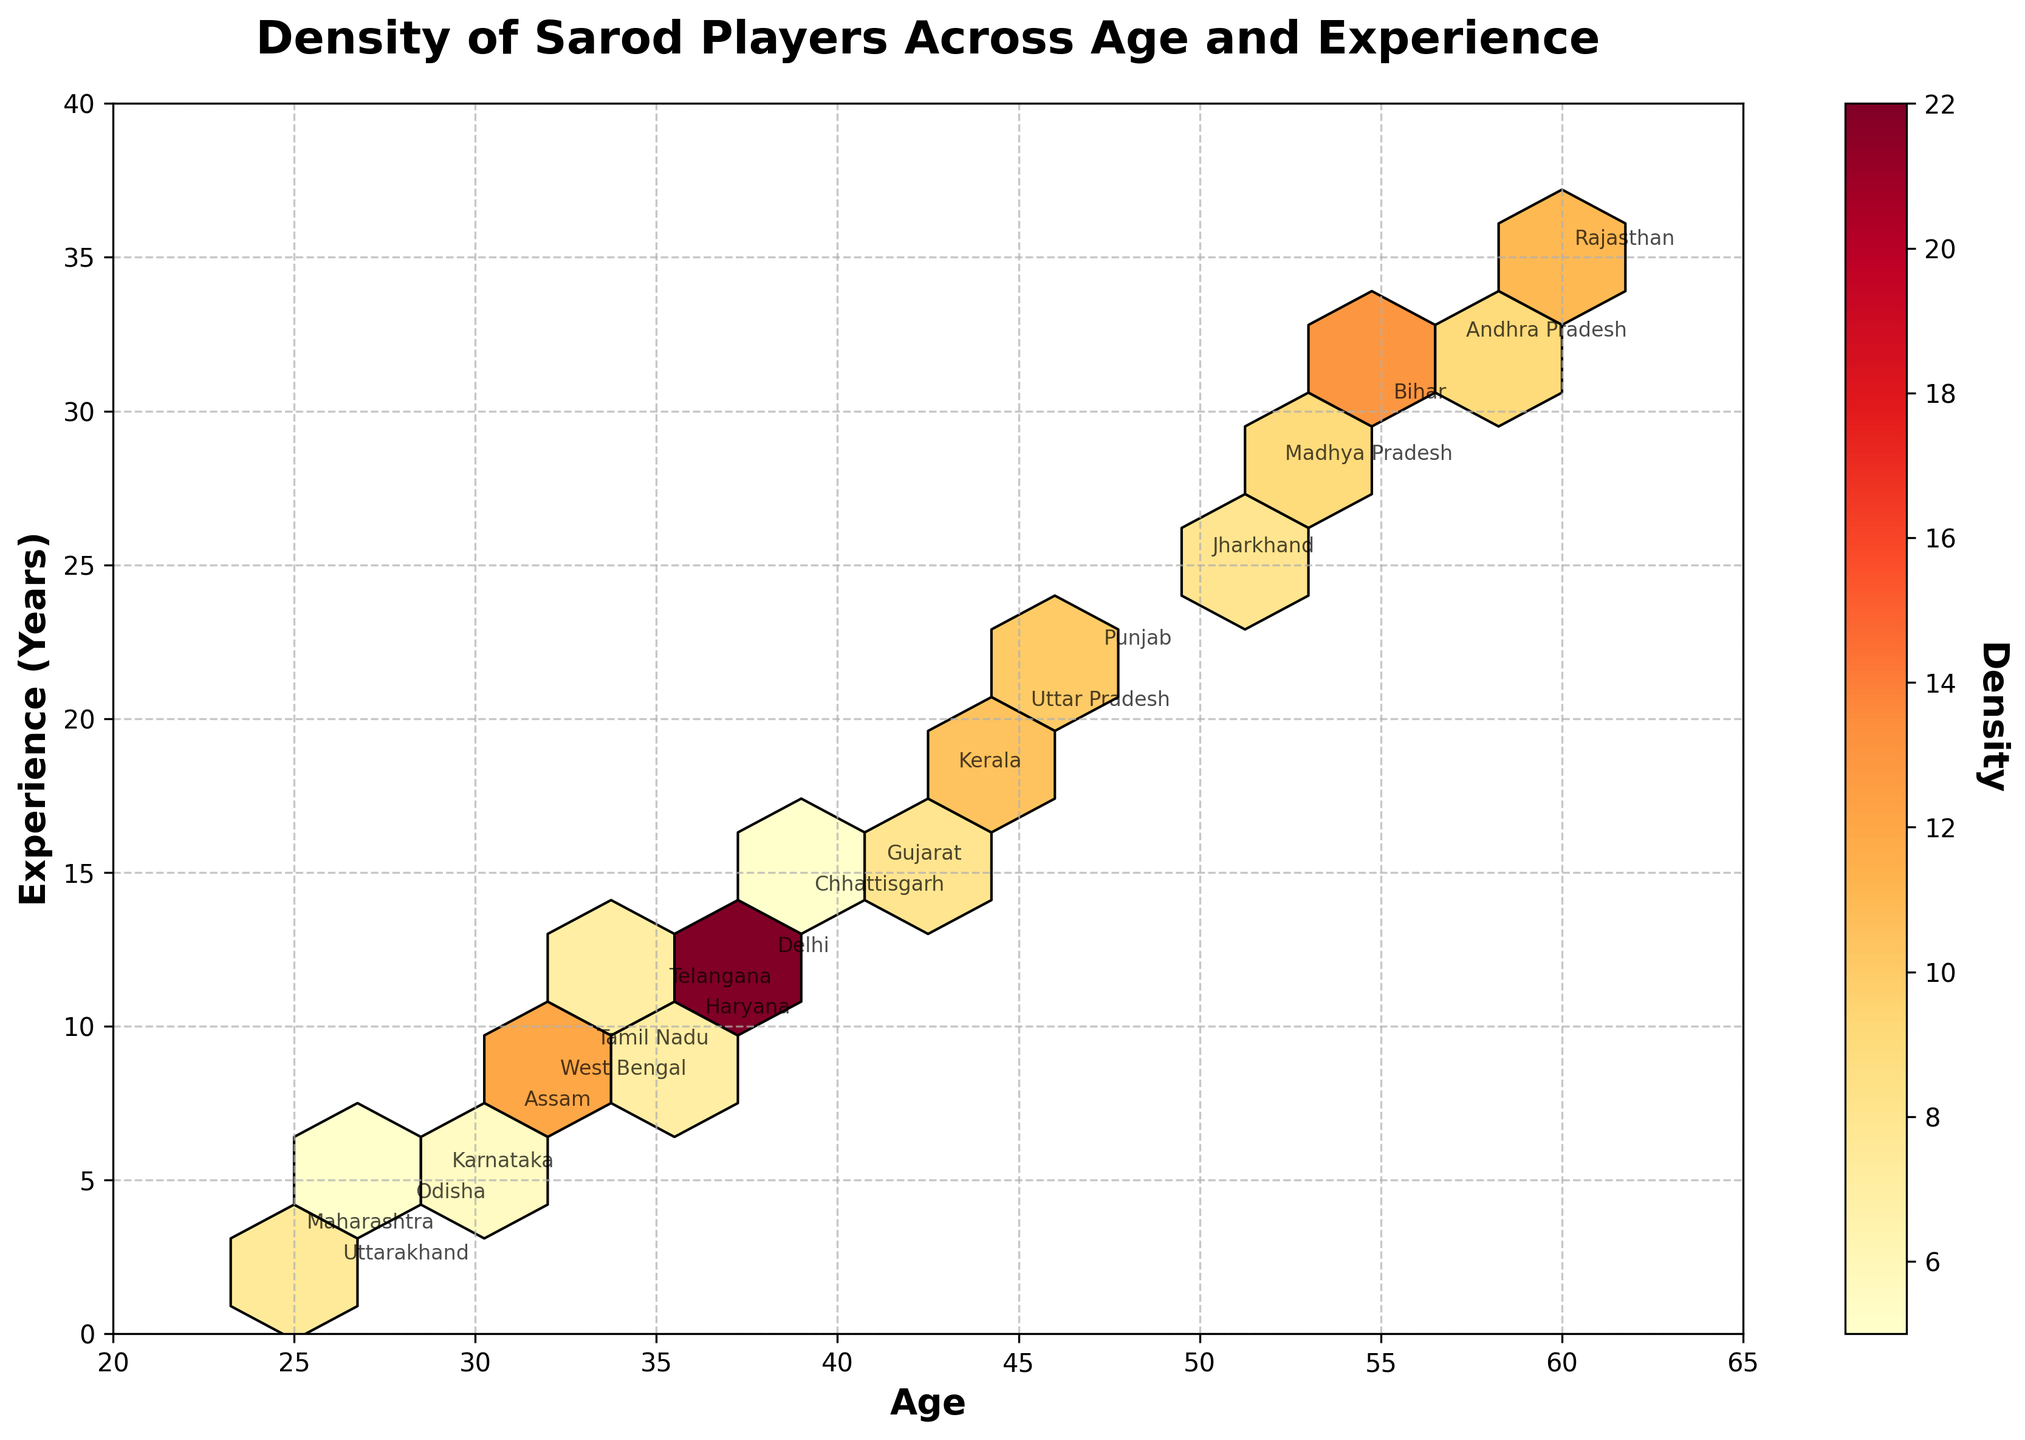What is the title of the figure? The title is located at the top of the figure, which summarizes the content or subject matter of the plot.
Answer: Density of Sarod Players Across Age and Experience What are the x and y axes representing in the figure? The x-axis and y-axis labels give information about what each axis represents. The x-axis is labeled 'Age' and the y-axis is labeled 'Experience (Years)'.
Answer: Age and Experience (Years) What color scheme is used to represent density in the hexbin plot? The color scheme is usually represented by a color bar on the side, showing a gradient from one color to another. In this figure, the color scheme ranges from light yellow to deep red.
Answer: Yellow to Red gradient Which state has the highest density value, and what are the age and experience levels associated with it? The highest density value can be found by looking at the darkest hexagon on the plot and identifying the state label nearest to it. In this plot, Delhi has the highest density value, which corresponds to an age of 38 and experience of 12 years.
Answer: Delhi, Age: 38, Experience: 12 Among the states depicted, which has the oldest sarod player and what is their experience level and density value? To find the oldest sarod player, look for the highest value on the x-axis (Age) and check the corresponding experience level and density value. The oldest sarod player is from Rajasthan with an age of 60, experience of 35 years, and density value of 11.
Answer: Rajasthan, Age: 60, Experience: 35, Density: 11 How does the density of sarod players vary with experience levels across different age groups? By examining the color gradient and distribution of hexagons, you can see where clusters form for different combinations of age and experience levels. Most higher density clusters appear around ages 30 to 55 with experience ranging from 10 to 30 years.
Answer: Higher density among ages 30-55 with 10-30 years of experience What are the density values for sarod players with less than 5 years of experience in different states? Identify hexagons where the y-axis value (Experience) is less than 5 and check nearby state labels. For Maharashtra, Density: 12; For Odisha, Density: 5; For Karnataka, Density: 7; For Uttarakhand, Density: 3.
Answer: Maharashtra: 12, Odisha: 5, Karnataka: 7, Uttarakhand: 3 Which state has the most experienced sarod player and what is their age and density value? Look for the highest value on the y-axis (Experience) and cross-reference the state, age, and density. Andhra Pradesh has the most experienced player with 32 years of experience, age 57, and a density value of 9.
Answer: Andhra Pradesh, Age: 57, Experience: 32, Density: 9 Is there any correlation between the age and experience levels of sarod players based on the plot? By analyzing the distribution and clustering of hexagons, age and experience levels seem to show a positive correlation as higher age often corresponds to higher experience levels. The trend is visible from the bottom-left to the top-right of the plot.
Answer: Positive correlation Which region seems to have a larger population of young and less experienced sarod players? Look in the plot's lower-left region for denser hexagons and corresponding state labels. States like Maharashtra and Uttarakhand have younger and less experienced sarod players indicated by higher densities in that region.
Answer: Maharashtra and Uttarakhand 